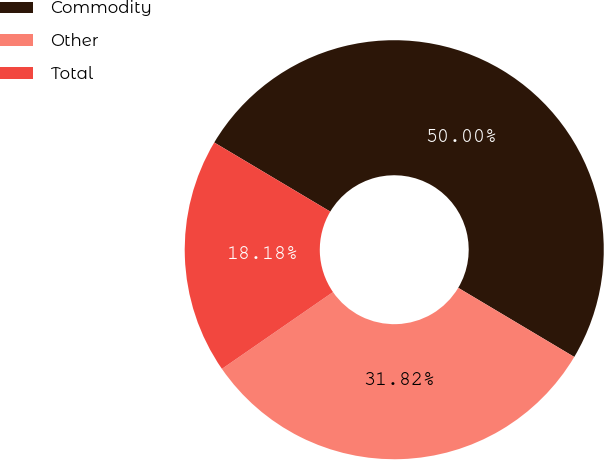Convert chart. <chart><loc_0><loc_0><loc_500><loc_500><pie_chart><fcel>Commodity<fcel>Other<fcel>Total<nl><fcel>50.0%<fcel>31.82%<fcel>18.18%<nl></chart> 